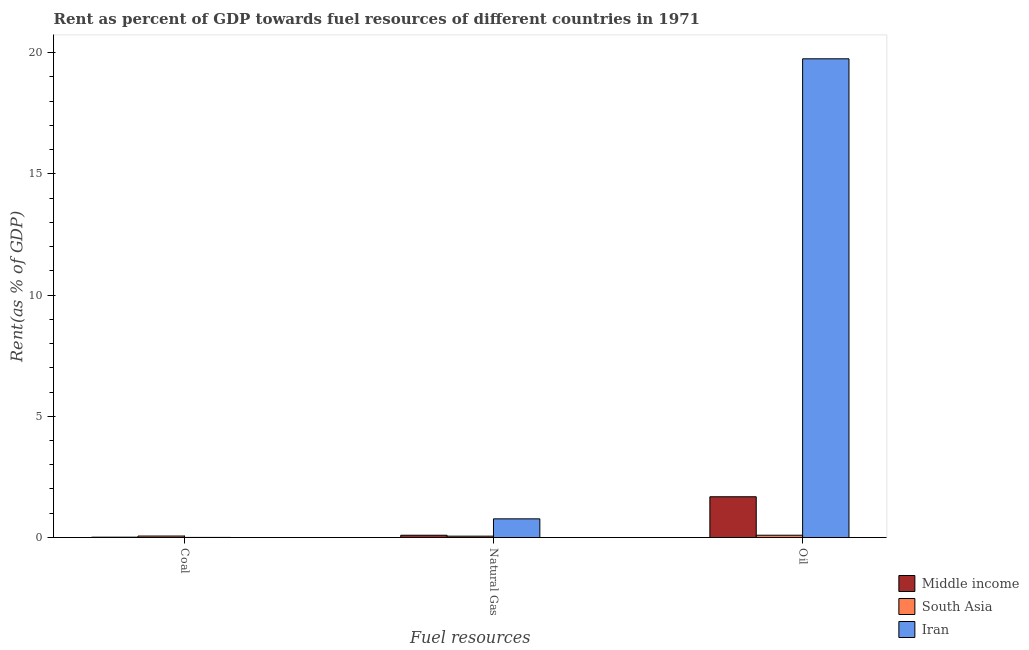How many different coloured bars are there?
Offer a very short reply. 3. How many groups of bars are there?
Ensure brevity in your answer.  3. Are the number of bars per tick equal to the number of legend labels?
Ensure brevity in your answer.  Yes. How many bars are there on the 3rd tick from the right?
Your answer should be compact. 3. What is the label of the 2nd group of bars from the left?
Make the answer very short. Natural Gas. What is the rent towards natural gas in South Asia?
Give a very brief answer. 0.05. Across all countries, what is the maximum rent towards oil?
Give a very brief answer. 19.74. Across all countries, what is the minimum rent towards natural gas?
Your answer should be compact. 0.05. In which country was the rent towards natural gas minimum?
Your answer should be very brief. South Asia. What is the total rent towards oil in the graph?
Provide a succinct answer. 21.52. What is the difference between the rent towards oil in South Asia and that in Middle income?
Your answer should be very brief. -1.59. What is the difference between the rent towards oil in Iran and the rent towards coal in Middle income?
Offer a very short reply. 19.73. What is the average rent towards coal per country?
Provide a succinct answer. 0.03. What is the difference between the rent towards oil and rent towards coal in Middle income?
Your answer should be compact. 1.67. What is the ratio of the rent towards natural gas in Middle income to that in South Asia?
Your answer should be very brief. 1.69. Is the rent towards coal in South Asia less than that in Iran?
Offer a terse response. No. What is the difference between the highest and the second highest rent towards oil?
Offer a terse response. 18.06. What is the difference between the highest and the lowest rent towards oil?
Provide a succinct answer. 19.65. In how many countries, is the rent towards oil greater than the average rent towards oil taken over all countries?
Provide a succinct answer. 1. Is the sum of the rent towards oil in Iran and Middle income greater than the maximum rent towards coal across all countries?
Give a very brief answer. Yes. What does the 1st bar from the left in Natural Gas represents?
Make the answer very short. Middle income. Is it the case that in every country, the sum of the rent towards coal and rent towards natural gas is greater than the rent towards oil?
Your answer should be compact. No. How many countries are there in the graph?
Provide a succinct answer. 3. Are the values on the major ticks of Y-axis written in scientific E-notation?
Offer a terse response. No. Does the graph contain any zero values?
Give a very brief answer. No. Does the graph contain grids?
Give a very brief answer. No. Where does the legend appear in the graph?
Offer a terse response. Bottom right. How many legend labels are there?
Your response must be concise. 3. How are the legend labels stacked?
Keep it short and to the point. Vertical. What is the title of the graph?
Make the answer very short. Rent as percent of GDP towards fuel resources of different countries in 1971. Does "Low & middle income" appear as one of the legend labels in the graph?
Offer a terse response. No. What is the label or title of the X-axis?
Offer a terse response. Fuel resources. What is the label or title of the Y-axis?
Your answer should be very brief. Rent(as % of GDP). What is the Rent(as % of GDP) in Middle income in Coal?
Your response must be concise. 0.01. What is the Rent(as % of GDP) in South Asia in Coal?
Your answer should be compact. 0.06. What is the Rent(as % of GDP) in Iran in Coal?
Provide a short and direct response. 0. What is the Rent(as % of GDP) in Middle income in Natural Gas?
Offer a terse response. 0.09. What is the Rent(as % of GDP) of South Asia in Natural Gas?
Offer a terse response. 0.05. What is the Rent(as % of GDP) of Iran in Natural Gas?
Offer a very short reply. 0.77. What is the Rent(as % of GDP) in Middle income in Oil?
Offer a very short reply. 1.68. What is the Rent(as % of GDP) in South Asia in Oil?
Offer a terse response. 0.09. What is the Rent(as % of GDP) of Iran in Oil?
Offer a terse response. 19.74. Across all Fuel resources, what is the maximum Rent(as % of GDP) in Middle income?
Keep it short and to the point. 1.68. Across all Fuel resources, what is the maximum Rent(as % of GDP) of South Asia?
Offer a very short reply. 0.09. Across all Fuel resources, what is the maximum Rent(as % of GDP) of Iran?
Your answer should be very brief. 19.74. Across all Fuel resources, what is the minimum Rent(as % of GDP) in Middle income?
Offer a very short reply. 0.01. Across all Fuel resources, what is the minimum Rent(as % of GDP) of South Asia?
Offer a terse response. 0.05. Across all Fuel resources, what is the minimum Rent(as % of GDP) in Iran?
Make the answer very short. 0. What is the total Rent(as % of GDP) of Middle income in the graph?
Keep it short and to the point. 1.79. What is the total Rent(as % of GDP) of South Asia in the graph?
Your answer should be compact. 0.21. What is the total Rent(as % of GDP) in Iran in the graph?
Make the answer very short. 20.52. What is the difference between the Rent(as % of GDP) in Middle income in Coal and that in Natural Gas?
Your answer should be very brief. -0.08. What is the difference between the Rent(as % of GDP) of South Asia in Coal and that in Natural Gas?
Your answer should be compact. 0.01. What is the difference between the Rent(as % of GDP) in Iran in Coal and that in Natural Gas?
Offer a terse response. -0.77. What is the difference between the Rent(as % of GDP) in Middle income in Coal and that in Oil?
Make the answer very short. -1.67. What is the difference between the Rent(as % of GDP) in South Asia in Coal and that in Oil?
Keep it short and to the point. -0.03. What is the difference between the Rent(as % of GDP) in Iran in Coal and that in Oil?
Your answer should be compact. -19.74. What is the difference between the Rent(as % of GDP) in Middle income in Natural Gas and that in Oil?
Keep it short and to the point. -1.59. What is the difference between the Rent(as % of GDP) of South Asia in Natural Gas and that in Oil?
Offer a very short reply. -0.04. What is the difference between the Rent(as % of GDP) of Iran in Natural Gas and that in Oil?
Ensure brevity in your answer.  -18.98. What is the difference between the Rent(as % of GDP) in Middle income in Coal and the Rent(as % of GDP) in South Asia in Natural Gas?
Provide a succinct answer. -0.04. What is the difference between the Rent(as % of GDP) of Middle income in Coal and the Rent(as % of GDP) of Iran in Natural Gas?
Ensure brevity in your answer.  -0.76. What is the difference between the Rent(as % of GDP) in South Asia in Coal and the Rent(as % of GDP) in Iran in Natural Gas?
Provide a succinct answer. -0.71. What is the difference between the Rent(as % of GDP) of Middle income in Coal and the Rent(as % of GDP) of South Asia in Oil?
Offer a terse response. -0.08. What is the difference between the Rent(as % of GDP) of Middle income in Coal and the Rent(as % of GDP) of Iran in Oil?
Make the answer very short. -19.73. What is the difference between the Rent(as % of GDP) in South Asia in Coal and the Rent(as % of GDP) in Iran in Oil?
Make the answer very short. -19.68. What is the difference between the Rent(as % of GDP) in Middle income in Natural Gas and the Rent(as % of GDP) in South Asia in Oil?
Ensure brevity in your answer.  -0. What is the difference between the Rent(as % of GDP) in Middle income in Natural Gas and the Rent(as % of GDP) in Iran in Oil?
Provide a succinct answer. -19.65. What is the difference between the Rent(as % of GDP) in South Asia in Natural Gas and the Rent(as % of GDP) in Iran in Oil?
Give a very brief answer. -19.69. What is the average Rent(as % of GDP) of Middle income per Fuel resources?
Your response must be concise. 0.6. What is the average Rent(as % of GDP) in South Asia per Fuel resources?
Offer a terse response. 0.07. What is the average Rent(as % of GDP) in Iran per Fuel resources?
Give a very brief answer. 6.84. What is the difference between the Rent(as % of GDP) of Middle income and Rent(as % of GDP) of South Asia in Coal?
Ensure brevity in your answer.  -0.05. What is the difference between the Rent(as % of GDP) of South Asia and Rent(as % of GDP) of Iran in Coal?
Provide a succinct answer. 0.06. What is the difference between the Rent(as % of GDP) in Middle income and Rent(as % of GDP) in South Asia in Natural Gas?
Give a very brief answer. 0.04. What is the difference between the Rent(as % of GDP) of Middle income and Rent(as % of GDP) of Iran in Natural Gas?
Keep it short and to the point. -0.68. What is the difference between the Rent(as % of GDP) in South Asia and Rent(as % of GDP) in Iran in Natural Gas?
Give a very brief answer. -0.71. What is the difference between the Rent(as % of GDP) of Middle income and Rent(as % of GDP) of South Asia in Oil?
Your answer should be very brief. 1.59. What is the difference between the Rent(as % of GDP) of Middle income and Rent(as % of GDP) of Iran in Oil?
Make the answer very short. -18.06. What is the difference between the Rent(as % of GDP) in South Asia and Rent(as % of GDP) in Iran in Oil?
Give a very brief answer. -19.65. What is the ratio of the Rent(as % of GDP) of Middle income in Coal to that in Natural Gas?
Your response must be concise. 0.14. What is the ratio of the Rent(as % of GDP) of South Asia in Coal to that in Natural Gas?
Make the answer very short. 1.1. What is the ratio of the Rent(as % of GDP) of Iran in Coal to that in Natural Gas?
Your answer should be compact. 0. What is the ratio of the Rent(as % of GDP) of Middle income in Coal to that in Oil?
Offer a terse response. 0.01. What is the ratio of the Rent(as % of GDP) of South Asia in Coal to that in Oil?
Offer a terse response. 0.64. What is the ratio of the Rent(as % of GDP) in Middle income in Natural Gas to that in Oil?
Make the answer very short. 0.06. What is the ratio of the Rent(as % of GDP) in South Asia in Natural Gas to that in Oil?
Make the answer very short. 0.58. What is the ratio of the Rent(as % of GDP) in Iran in Natural Gas to that in Oil?
Provide a succinct answer. 0.04. What is the difference between the highest and the second highest Rent(as % of GDP) of Middle income?
Give a very brief answer. 1.59. What is the difference between the highest and the second highest Rent(as % of GDP) in Iran?
Keep it short and to the point. 18.98. What is the difference between the highest and the lowest Rent(as % of GDP) in Middle income?
Make the answer very short. 1.67. What is the difference between the highest and the lowest Rent(as % of GDP) in South Asia?
Your answer should be very brief. 0.04. What is the difference between the highest and the lowest Rent(as % of GDP) in Iran?
Ensure brevity in your answer.  19.74. 